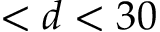Convert formula to latex. <formula><loc_0><loc_0><loc_500><loc_500>< d < 3 0</formula> 